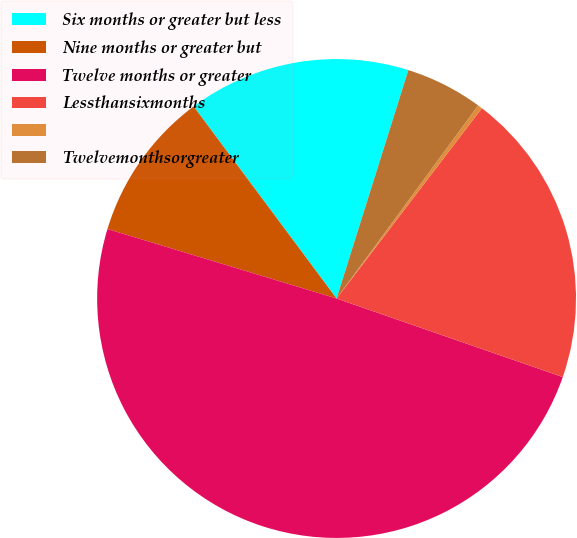Convert chart to OTSL. <chart><loc_0><loc_0><loc_500><loc_500><pie_chart><fcel>Six months or greater but less<fcel>Nine months or greater but<fcel>Twelve months or greater<fcel>Lessthansixmonths<fcel>Unnamed: 4<fcel>Twelvemonthsorgreater<nl><fcel>15.03%<fcel>10.13%<fcel>49.37%<fcel>19.94%<fcel>0.31%<fcel>5.22%<nl></chart> 